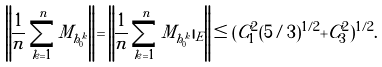Convert formula to latex. <formula><loc_0><loc_0><loc_500><loc_500>\left \| \frac { 1 } { n } \sum _ { k = 1 } ^ { n } M _ { h _ { 0 } ^ { k } } \right \| = \left \| \frac { 1 } { n } \sum _ { k = 1 } ^ { n } M _ { h _ { 0 } ^ { k } } | _ { E } \right \| \leq ( C ^ { 2 } _ { 1 } ( 5 / 3 ) ^ { 1 / 2 } + C _ { 3 } ^ { 2 } ) ^ { 1 / 2 } .</formula> 